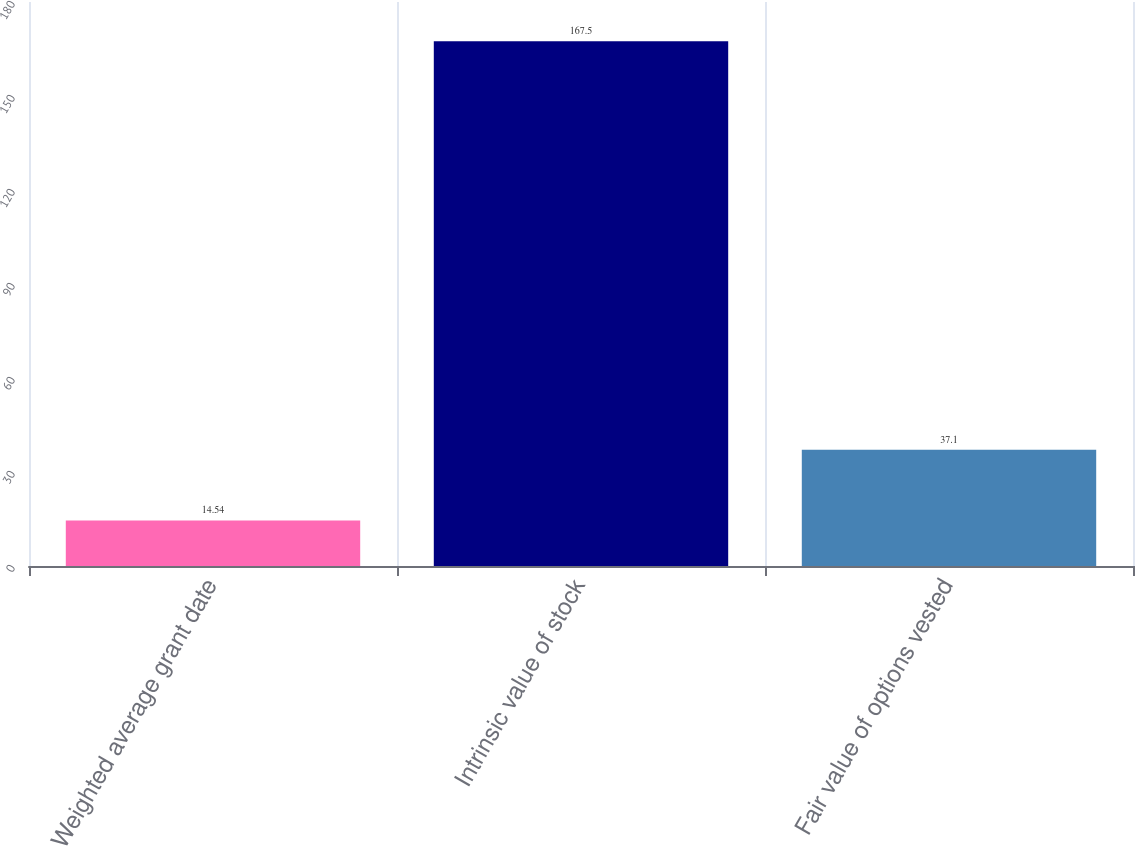Convert chart. <chart><loc_0><loc_0><loc_500><loc_500><bar_chart><fcel>Weighted average grant date<fcel>Intrinsic value of stock<fcel>Fair value of options vested<nl><fcel>14.54<fcel>167.5<fcel>37.1<nl></chart> 